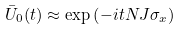<formula> <loc_0><loc_0><loc_500><loc_500>\bar { U } _ { 0 } ( t ) \approx \exp \left ( - i t N J \sigma _ { x } \right )</formula> 